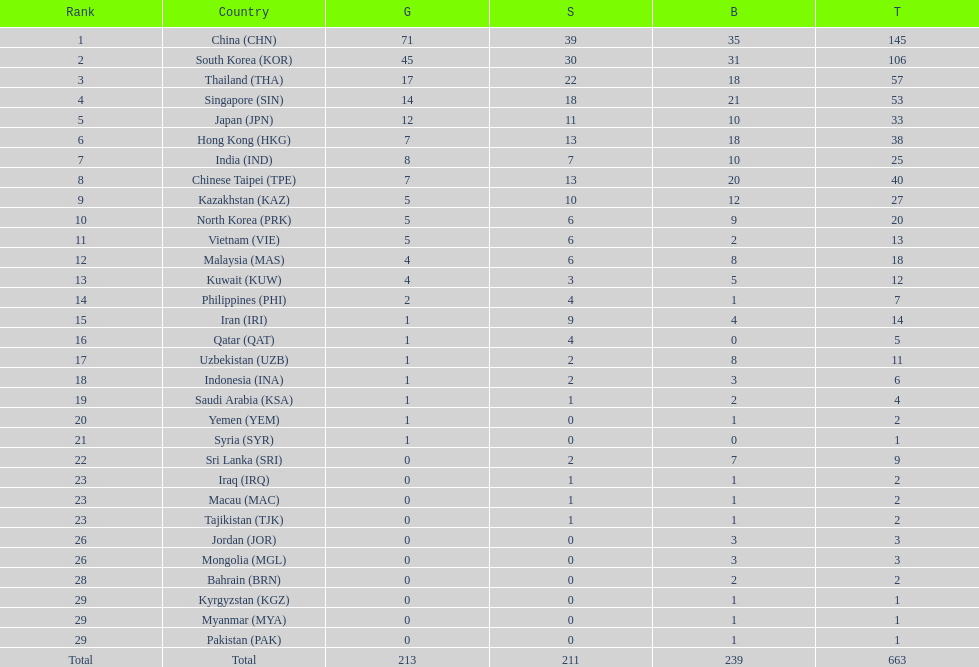Which nation has more gold medals, kuwait or india? India (IND). 